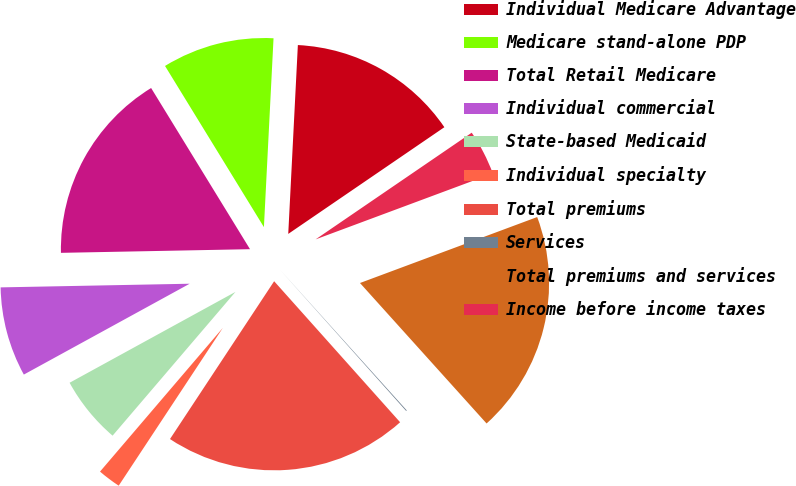Convert chart. <chart><loc_0><loc_0><loc_500><loc_500><pie_chart><fcel>Individual Medicare Advantage<fcel>Medicare stand-alone PDP<fcel>Total Retail Medicare<fcel>Individual commercial<fcel>State-based Medicaid<fcel>Individual specialty<fcel>Total premiums<fcel>Services<fcel>Total premiums and services<fcel>Income before income taxes<nl><fcel>14.65%<fcel>9.57%<fcel>16.55%<fcel>7.67%<fcel>5.77%<fcel>1.97%<fcel>20.89%<fcel>0.07%<fcel>19.0%<fcel>3.87%<nl></chart> 